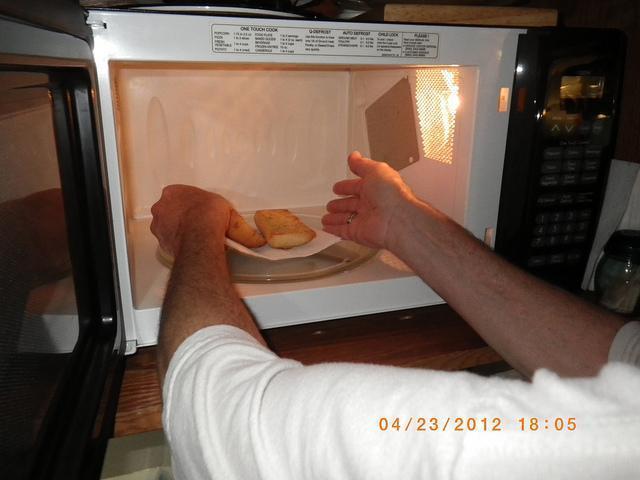How many chairs are seated around the bar top?
Give a very brief answer. 0. 